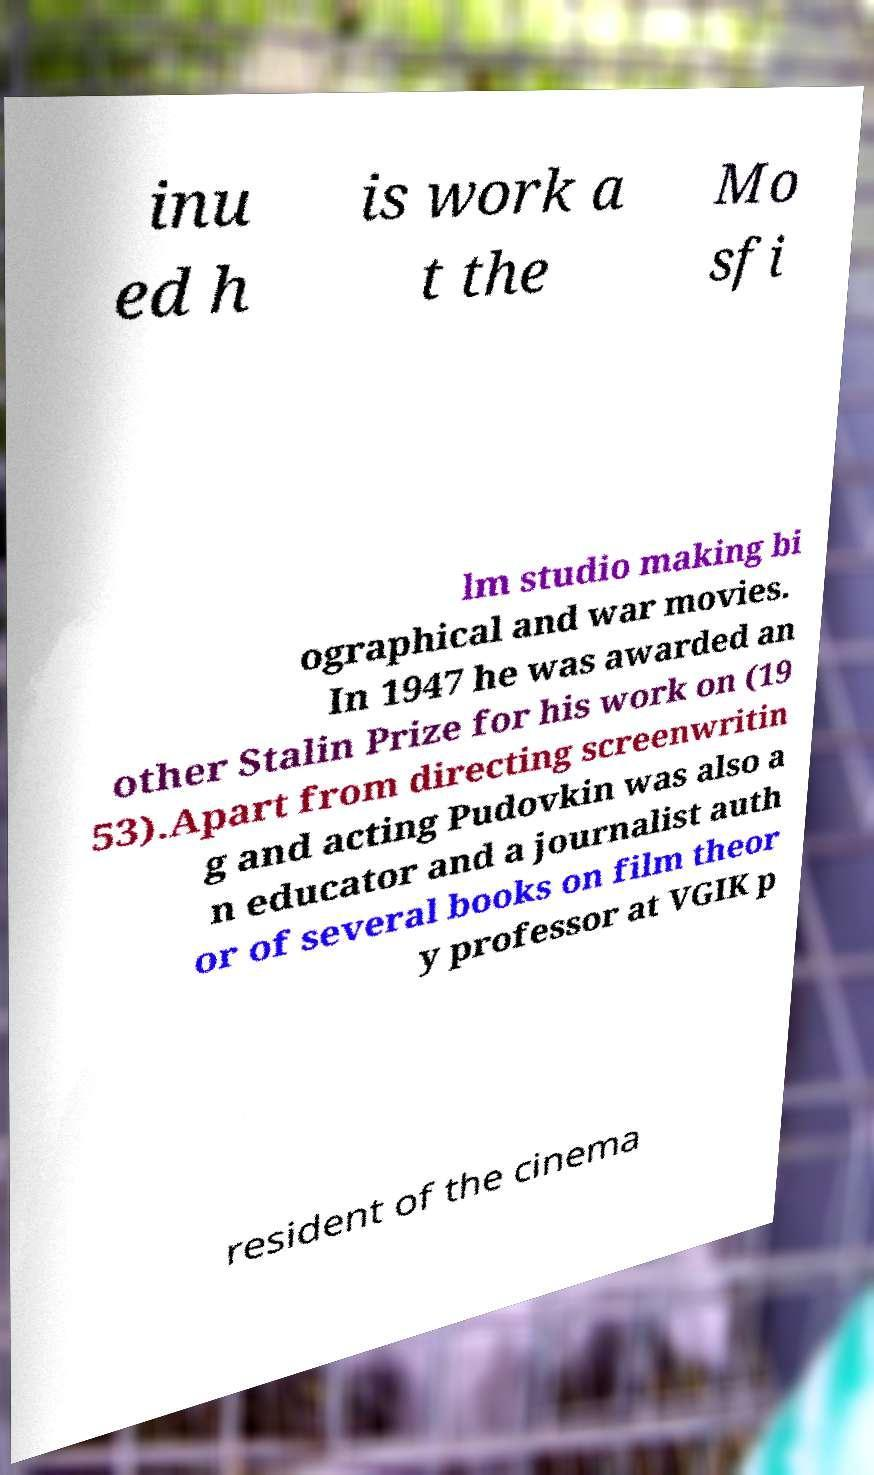Please read and relay the text visible in this image. What does it say? inu ed h is work a t the Mo sfi lm studio making bi ographical and war movies. In 1947 he was awarded an other Stalin Prize for his work on (19 53).Apart from directing screenwritin g and acting Pudovkin was also a n educator and a journalist auth or of several books on film theor y professor at VGIK p resident of the cinema 